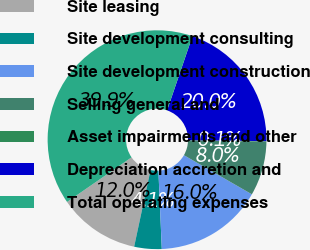Convert chart to OTSL. <chart><loc_0><loc_0><loc_500><loc_500><pie_chart><fcel>Site leasing<fcel>Site development consulting<fcel>Site development construction<fcel>Selling general and<fcel>Asset impairments and other<fcel>Depreciation accretion and<fcel>Total operating expenses<nl><fcel>12.01%<fcel>4.05%<fcel>15.99%<fcel>8.03%<fcel>0.07%<fcel>19.97%<fcel>39.87%<nl></chart> 